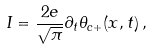<formula> <loc_0><loc_0><loc_500><loc_500>I = \frac { 2 e } { \sqrt { \pi } } \partial _ { t } \theta _ { c + } ( x , t ) \, ,</formula> 